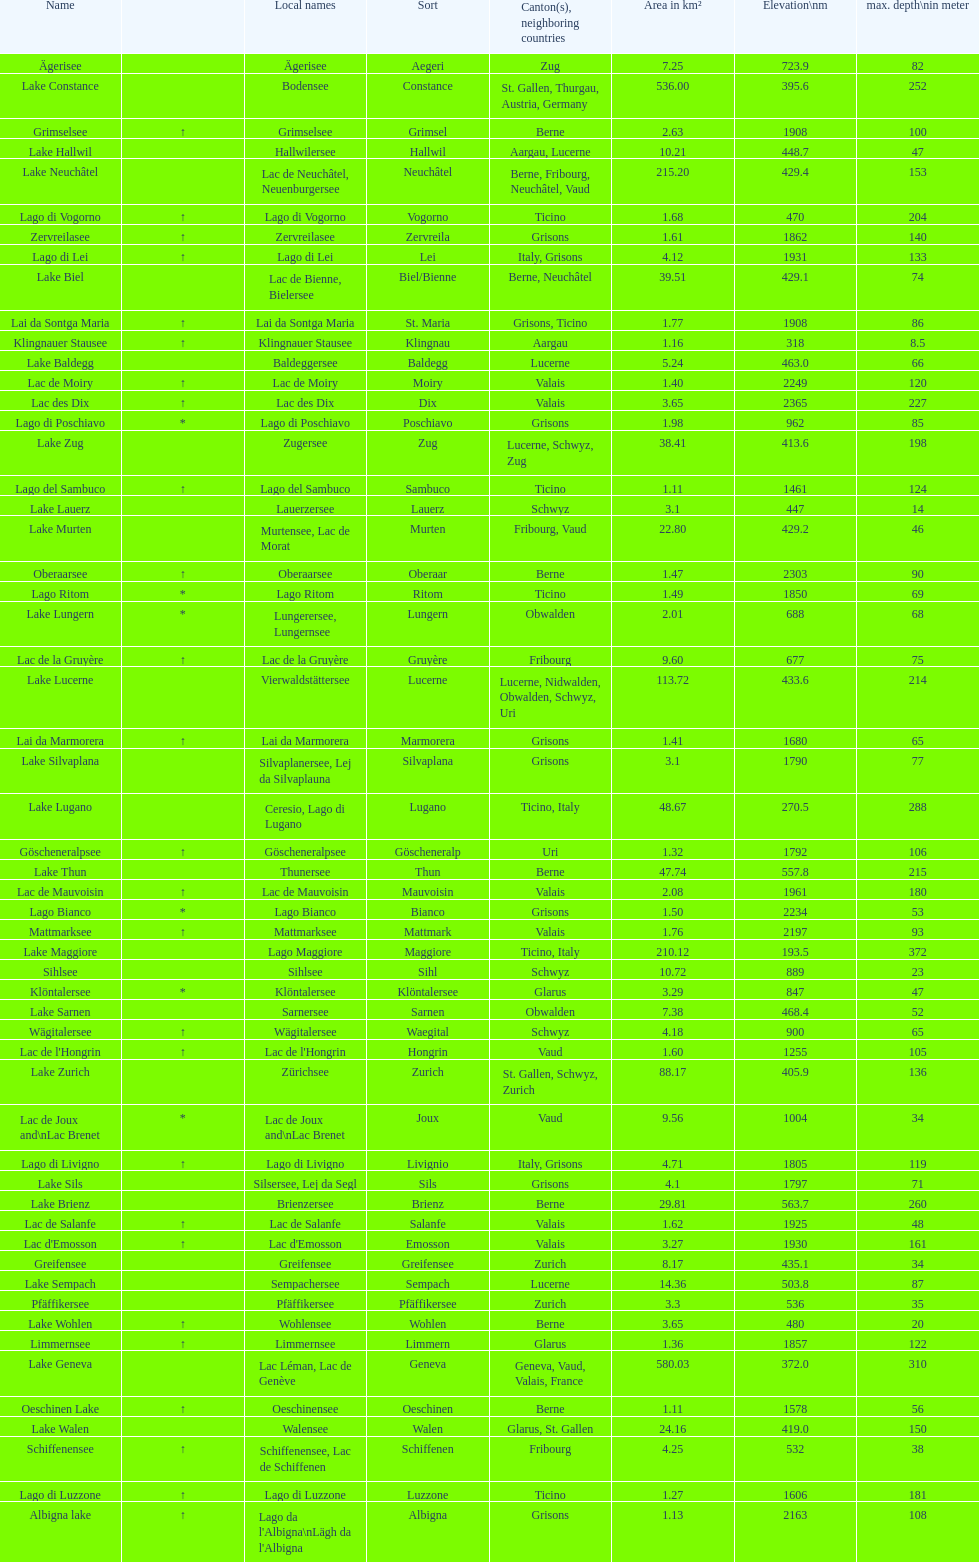Which lake has the largest elevation? Lac des Dix. 